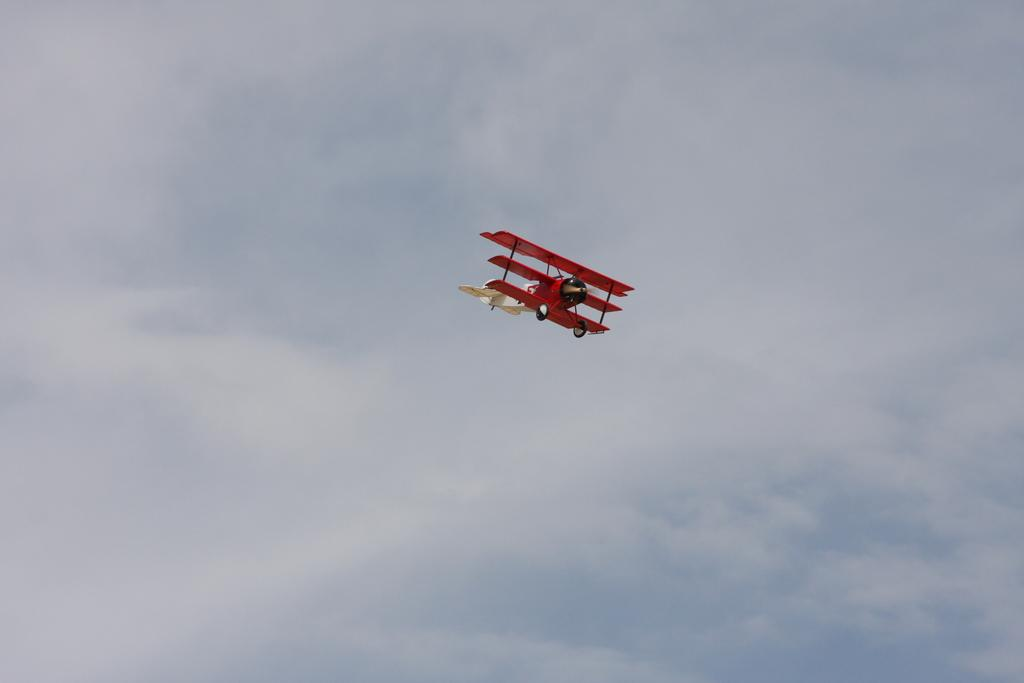What is happening in the sky in the image? There is a flight in the sky in the image. Can you describe the flight in more detail? Unfortunately, the provided facts do not offer more detail about the flight. Is there any other object or event happening in the image besides the flight? No, the only information given is that there is a flight in the sky. What type of attraction can be seen in the image? There is no attraction present in the image; it only features a flight in the sky. How does the cub adjust to the flight in the image? There is no cub present in the image, so it cannot adjust to the flight. 